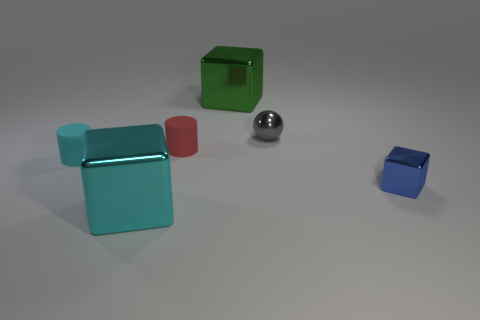Is there anything else that is made of the same material as the small cyan thing?
Your answer should be compact. Yes. There is a large cube in front of the blue thing; does it have the same color as the rubber thing that is to the left of the cyan cube?
Ensure brevity in your answer.  Yes. What is the shape of the metallic object that is both in front of the large green object and on the left side of the tiny gray metal object?
Ensure brevity in your answer.  Cube. There is a small metal sphere; are there any metal things to the left of it?
Your response must be concise. Yes. Is there any other thing that is the same shape as the small gray metal object?
Ensure brevity in your answer.  No. Is the red matte object the same shape as the cyan metallic thing?
Your response must be concise. No. Is the number of blue cubes behind the tiny metal cube the same as the number of small matte cylinders behind the tiny cyan thing?
Your answer should be very brief. No. What number of other things are the same material as the red cylinder?
Make the answer very short. 1. What number of small things are either cyan metal blocks or green cubes?
Provide a succinct answer. 0. Are there an equal number of shiny balls in front of the small blue shiny thing and large yellow rubber cylinders?
Give a very brief answer. Yes. 